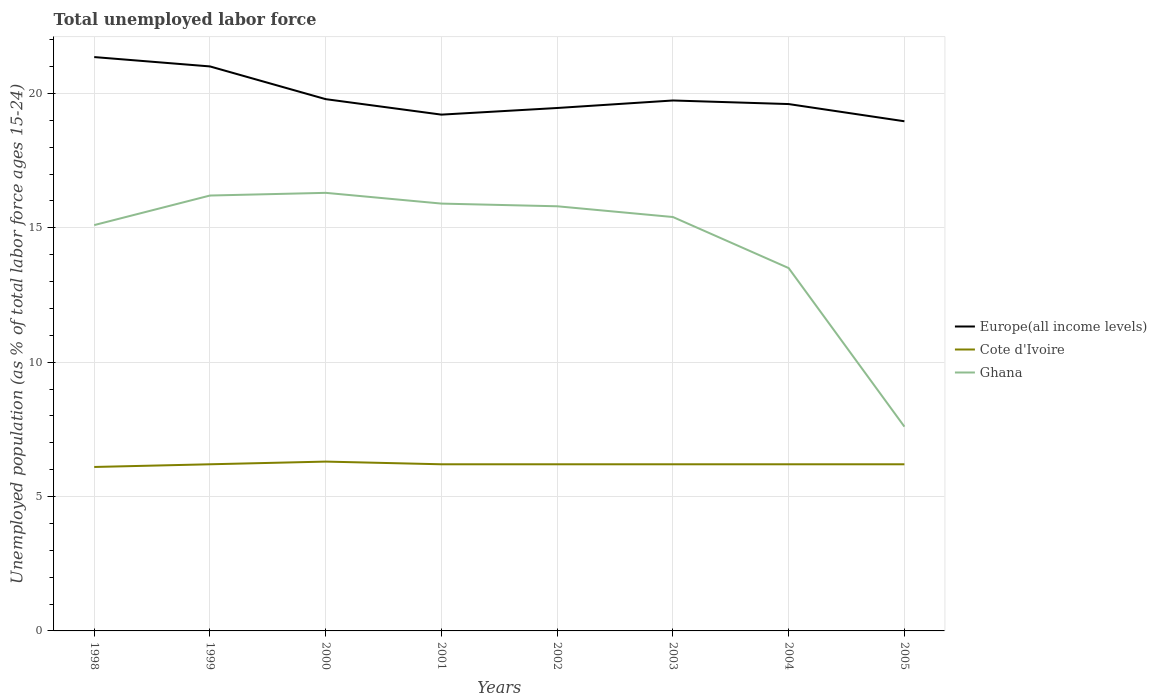Is the number of lines equal to the number of legend labels?
Ensure brevity in your answer.  Yes. Across all years, what is the maximum percentage of unemployed population in in Cote d'Ivoire?
Provide a short and direct response. 6.1. What is the total percentage of unemployed population in in Europe(all income levels) in the graph?
Make the answer very short. -0.39. What is the difference between the highest and the second highest percentage of unemployed population in in Ghana?
Keep it short and to the point. 8.7. How many lines are there?
Provide a succinct answer. 3. How many years are there in the graph?
Give a very brief answer. 8. What is the difference between two consecutive major ticks on the Y-axis?
Keep it short and to the point. 5. Are the values on the major ticks of Y-axis written in scientific E-notation?
Ensure brevity in your answer.  No. Does the graph contain any zero values?
Provide a short and direct response. No. Does the graph contain grids?
Offer a terse response. Yes. How are the legend labels stacked?
Offer a terse response. Vertical. What is the title of the graph?
Offer a very short reply. Total unemployed labor force. What is the label or title of the X-axis?
Offer a very short reply. Years. What is the label or title of the Y-axis?
Offer a terse response. Unemployed population (as % of total labor force ages 15-24). What is the Unemployed population (as % of total labor force ages 15-24) of Europe(all income levels) in 1998?
Provide a succinct answer. 21.35. What is the Unemployed population (as % of total labor force ages 15-24) in Cote d'Ivoire in 1998?
Provide a succinct answer. 6.1. What is the Unemployed population (as % of total labor force ages 15-24) in Ghana in 1998?
Make the answer very short. 15.1. What is the Unemployed population (as % of total labor force ages 15-24) of Europe(all income levels) in 1999?
Provide a succinct answer. 21. What is the Unemployed population (as % of total labor force ages 15-24) in Cote d'Ivoire in 1999?
Make the answer very short. 6.2. What is the Unemployed population (as % of total labor force ages 15-24) in Ghana in 1999?
Your response must be concise. 16.2. What is the Unemployed population (as % of total labor force ages 15-24) of Europe(all income levels) in 2000?
Offer a terse response. 19.79. What is the Unemployed population (as % of total labor force ages 15-24) in Cote d'Ivoire in 2000?
Offer a very short reply. 6.3. What is the Unemployed population (as % of total labor force ages 15-24) in Ghana in 2000?
Offer a terse response. 16.3. What is the Unemployed population (as % of total labor force ages 15-24) of Europe(all income levels) in 2001?
Your answer should be compact. 19.21. What is the Unemployed population (as % of total labor force ages 15-24) of Cote d'Ivoire in 2001?
Your answer should be compact. 6.2. What is the Unemployed population (as % of total labor force ages 15-24) of Ghana in 2001?
Your response must be concise. 15.9. What is the Unemployed population (as % of total labor force ages 15-24) of Europe(all income levels) in 2002?
Your response must be concise. 19.46. What is the Unemployed population (as % of total labor force ages 15-24) of Cote d'Ivoire in 2002?
Your response must be concise. 6.2. What is the Unemployed population (as % of total labor force ages 15-24) in Ghana in 2002?
Your response must be concise. 15.8. What is the Unemployed population (as % of total labor force ages 15-24) of Europe(all income levels) in 2003?
Keep it short and to the point. 19.74. What is the Unemployed population (as % of total labor force ages 15-24) of Cote d'Ivoire in 2003?
Offer a terse response. 6.2. What is the Unemployed population (as % of total labor force ages 15-24) of Ghana in 2003?
Offer a very short reply. 15.4. What is the Unemployed population (as % of total labor force ages 15-24) of Europe(all income levels) in 2004?
Your answer should be compact. 19.6. What is the Unemployed population (as % of total labor force ages 15-24) of Cote d'Ivoire in 2004?
Give a very brief answer. 6.2. What is the Unemployed population (as % of total labor force ages 15-24) of Europe(all income levels) in 2005?
Your answer should be very brief. 18.96. What is the Unemployed population (as % of total labor force ages 15-24) of Cote d'Ivoire in 2005?
Your answer should be very brief. 6.2. What is the Unemployed population (as % of total labor force ages 15-24) in Ghana in 2005?
Keep it short and to the point. 7.6. Across all years, what is the maximum Unemployed population (as % of total labor force ages 15-24) in Europe(all income levels)?
Your response must be concise. 21.35. Across all years, what is the maximum Unemployed population (as % of total labor force ages 15-24) in Cote d'Ivoire?
Offer a very short reply. 6.3. Across all years, what is the maximum Unemployed population (as % of total labor force ages 15-24) in Ghana?
Make the answer very short. 16.3. Across all years, what is the minimum Unemployed population (as % of total labor force ages 15-24) in Europe(all income levels)?
Ensure brevity in your answer.  18.96. Across all years, what is the minimum Unemployed population (as % of total labor force ages 15-24) in Cote d'Ivoire?
Make the answer very short. 6.1. Across all years, what is the minimum Unemployed population (as % of total labor force ages 15-24) of Ghana?
Keep it short and to the point. 7.6. What is the total Unemployed population (as % of total labor force ages 15-24) in Europe(all income levels) in the graph?
Offer a terse response. 159.11. What is the total Unemployed population (as % of total labor force ages 15-24) of Cote d'Ivoire in the graph?
Provide a succinct answer. 49.6. What is the total Unemployed population (as % of total labor force ages 15-24) of Ghana in the graph?
Offer a very short reply. 115.8. What is the difference between the Unemployed population (as % of total labor force ages 15-24) in Europe(all income levels) in 1998 and that in 1999?
Provide a succinct answer. 0.35. What is the difference between the Unemployed population (as % of total labor force ages 15-24) of Cote d'Ivoire in 1998 and that in 1999?
Your answer should be compact. -0.1. What is the difference between the Unemployed population (as % of total labor force ages 15-24) in Ghana in 1998 and that in 1999?
Provide a succinct answer. -1.1. What is the difference between the Unemployed population (as % of total labor force ages 15-24) of Europe(all income levels) in 1998 and that in 2000?
Your answer should be very brief. 1.57. What is the difference between the Unemployed population (as % of total labor force ages 15-24) in Europe(all income levels) in 1998 and that in 2001?
Offer a terse response. 2.14. What is the difference between the Unemployed population (as % of total labor force ages 15-24) of Ghana in 1998 and that in 2001?
Offer a very short reply. -0.8. What is the difference between the Unemployed population (as % of total labor force ages 15-24) of Europe(all income levels) in 1998 and that in 2002?
Provide a succinct answer. 1.89. What is the difference between the Unemployed population (as % of total labor force ages 15-24) in Cote d'Ivoire in 1998 and that in 2002?
Your response must be concise. -0.1. What is the difference between the Unemployed population (as % of total labor force ages 15-24) of Ghana in 1998 and that in 2002?
Ensure brevity in your answer.  -0.7. What is the difference between the Unemployed population (as % of total labor force ages 15-24) in Europe(all income levels) in 1998 and that in 2003?
Give a very brief answer. 1.62. What is the difference between the Unemployed population (as % of total labor force ages 15-24) in Ghana in 1998 and that in 2003?
Offer a very short reply. -0.3. What is the difference between the Unemployed population (as % of total labor force ages 15-24) in Europe(all income levels) in 1998 and that in 2004?
Your answer should be very brief. 1.75. What is the difference between the Unemployed population (as % of total labor force ages 15-24) of Cote d'Ivoire in 1998 and that in 2004?
Ensure brevity in your answer.  -0.1. What is the difference between the Unemployed population (as % of total labor force ages 15-24) in Europe(all income levels) in 1998 and that in 2005?
Give a very brief answer. 2.39. What is the difference between the Unemployed population (as % of total labor force ages 15-24) of Ghana in 1998 and that in 2005?
Offer a very short reply. 7.5. What is the difference between the Unemployed population (as % of total labor force ages 15-24) in Europe(all income levels) in 1999 and that in 2000?
Keep it short and to the point. 1.22. What is the difference between the Unemployed population (as % of total labor force ages 15-24) in Ghana in 1999 and that in 2000?
Make the answer very short. -0.1. What is the difference between the Unemployed population (as % of total labor force ages 15-24) in Europe(all income levels) in 1999 and that in 2001?
Provide a short and direct response. 1.79. What is the difference between the Unemployed population (as % of total labor force ages 15-24) in Cote d'Ivoire in 1999 and that in 2001?
Provide a succinct answer. 0. What is the difference between the Unemployed population (as % of total labor force ages 15-24) of Europe(all income levels) in 1999 and that in 2002?
Provide a succinct answer. 1.55. What is the difference between the Unemployed population (as % of total labor force ages 15-24) of Ghana in 1999 and that in 2002?
Your answer should be compact. 0.4. What is the difference between the Unemployed population (as % of total labor force ages 15-24) in Europe(all income levels) in 1999 and that in 2003?
Offer a very short reply. 1.27. What is the difference between the Unemployed population (as % of total labor force ages 15-24) of Cote d'Ivoire in 1999 and that in 2003?
Ensure brevity in your answer.  0. What is the difference between the Unemployed population (as % of total labor force ages 15-24) of Ghana in 1999 and that in 2003?
Provide a short and direct response. 0.8. What is the difference between the Unemployed population (as % of total labor force ages 15-24) in Europe(all income levels) in 1999 and that in 2004?
Your answer should be very brief. 1.4. What is the difference between the Unemployed population (as % of total labor force ages 15-24) in Ghana in 1999 and that in 2004?
Your answer should be compact. 2.7. What is the difference between the Unemployed population (as % of total labor force ages 15-24) in Europe(all income levels) in 1999 and that in 2005?
Your answer should be compact. 2.04. What is the difference between the Unemployed population (as % of total labor force ages 15-24) in Europe(all income levels) in 2000 and that in 2001?
Provide a short and direct response. 0.58. What is the difference between the Unemployed population (as % of total labor force ages 15-24) of Cote d'Ivoire in 2000 and that in 2001?
Offer a very short reply. 0.1. What is the difference between the Unemployed population (as % of total labor force ages 15-24) in Ghana in 2000 and that in 2001?
Give a very brief answer. 0.4. What is the difference between the Unemployed population (as % of total labor force ages 15-24) of Europe(all income levels) in 2000 and that in 2002?
Ensure brevity in your answer.  0.33. What is the difference between the Unemployed population (as % of total labor force ages 15-24) of Cote d'Ivoire in 2000 and that in 2002?
Offer a terse response. 0.1. What is the difference between the Unemployed population (as % of total labor force ages 15-24) in Europe(all income levels) in 2000 and that in 2003?
Your response must be concise. 0.05. What is the difference between the Unemployed population (as % of total labor force ages 15-24) in Cote d'Ivoire in 2000 and that in 2003?
Offer a very short reply. 0.1. What is the difference between the Unemployed population (as % of total labor force ages 15-24) of Europe(all income levels) in 2000 and that in 2004?
Ensure brevity in your answer.  0.18. What is the difference between the Unemployed population (as % of total labor force ages 15-24) in Ghana in 2000 and that in 2004?
Give a very brief answer. 2.8. What is the difference between the Unemployed population (as % of total labor force ages 15-24) in Europe(all income levels) in 2000 and that in 2005?
Offer a very short reply. 0.82. What is the difference between the Unemployed population (as % of total labor force ages 15-24) of Ghana in 2000 and that in 2005?
Your answer should be compact. 8.7. What is the difference between the Unemployed population (as % of total labor force ages 15-24) in Europe(all income levels) in 2001 and that in 2002?
Offer a very short reply. -0.25. What is the difference between the Unemployed population (as % of total labor force ages 15-24) in Cote d'Ivoire in 2001 and that in 2002?
Provide a short and direct response. 0. What is the difference between the Unemployed population (as % of total labor force ages 15-24) of Ghana in 2001 and that in 2002?
Ensure brevity in your answer.  0.1. What is the difference between the Unemployed population (as % of total labor force ages 15-24) in Europe(all income levels) in 2001 and that in 2003?
Your answer should be very brief. -0.53. What is the difference between the Unemployed population (as % of total labor force ages 15-24) of Europe(all income levels) in 2001 and that in 2004?
Provide a short and direct response. -0.39. What is the difference between the Unemployed population (as % of total labor force ages 15-24) in Cote d'Ivoire in 2001 and that in 2004?
Provide a short and direct response. 0. What is the difference between the Unemployed population (as % of total labor force ages 15-24) in Europe(all income levels) in 2001 and that in 2005?
Your answer should be very brief. 0.25. What is the difference between the Unemployed population (as % of total labor force ages 15-24) of Europe(all income levels) in 2002 and that in 2003?
Provide a short and direct response. -0.28. What is the difference between the Unemployed population (as % of total labor force ages 15-24) of Cote d'Ivoire in 2002 and that in 2003?
Ensure brevity in your answer.  0. What is the difference between the Unemployed population (as % of total labor force ages 15-24) of Europe(all income levels) in 2002 and that in 2004?
Your answer should be very brief. -0.15. What is the difference between the Unemployed population (as % of total labor force ages 15-24) of Ghana in 2002 and that in 2004?
Your answer should be compact. 2.3. What is the difference between the Unemployed population (as % of total labor force ages 15-24) of Europe(all income levels) in 2002 and that in 2005?
Your answer should be very brief. 0.49. What is the difference between the Unemployed population (as % of total labor force ages 15-24) in Cote d'Ivoire in 2002 and that in 2005?
Give a very brief answer. 0. What is the difference between the Unemployed population (as % of total labor force ages 15-24) in Ghana in 2002 and that in 2005?
Keep it short and to the point. 8.2. What is the difference between the Unemployed population (as % of total labor force ages 15-24) in Europe(all income levels) in 2003 and that in 2004?
Make the answer very short. 0.13. What is the difference between the Unemployed population (as % of total labor force ages 15-24) of Cote d'Ivoire in 2003 and that in 2004?
Give a very brief answer. 0. What is the difference between the Unemployed population (as % of total labor force ages 15-24) of Europe(all income levels) in 2003 and that in 2005?
Keep it short and to the point. 0.77. What is the difference between the Unemployed population (as % of total labor force ages 15-24) in Cote d'Ivoire in 2003 and that in 2005?
Provide a succinct answer. 0. What is the difference between the Unemployed population (as % of total labor force ages 15-24) in Ghana in 2003 and that in 2005?
Make the answer very short. 7.8. What is the difference between the Unemployed population (as % of total labor force ages 15-24) in Europe(all income levels) in 2004 and that in 2005?
Offer a very short reply. 0.64. What is the difference between the Unemployed population (as % of total labor force ages 15-24) of Ghana in 2004 and that in 2005?
Offer a terse response. 5.9. What is the difference between the Unemployed population (as % of total labor force ages 15-24) in Europe(all income levels) in 1998 and the Unemployed population (as % of total labor force ages 15-24) in Cote d'Ivoire in 1999?
Your response must be concise. 15.15. What is the difference between the Unemployed population (as % of total labor force ages 15-24) in Europe(all income levels) in 1998 and the Unemployed population (as % of total labor force ages 15-24) in Ghana in 1999?
Offer a very short reply. 5.15. What is the difference between the Unemployed population (as % of total labor force ages 15-24) of Europe(all income levels) in 1998 and the Unemployed population (as % of total labor force ages 15-24) of Cote d'Ivoire in 2000?
Provide a succinct answer. 15.05. What is the difference between the Unemployed population (as % of total labor force ages 15-24) in Europe(all income levels) in 1998 and the Unemployed population (as % of total labor force ages 15-24) in Ghana in 2000?
Offer a terse response. 5.05. What is the difference between the Unemployed population (as % of total labor force ages 15-24) of Europe(all income levels) in 1998 and the Unemployed population (as % of total labor force ages 15-24) of Cote d'Ivoire in 2001?
Provide a short and direct response. 15.15. What is the difference between the Unemployed population (as % of total labor force ages 15-24) of Europe(all income levels) in 1998 and the Unemployed population (as % of total labor force ages 15-24) of Ghana in 2001?
Provide a succinct answer. 5.45. What is the difference between the Unemployed population (as % of total labor force ages 15-24) of Europe(all income levels) in 1998 and the Unemployed population (as % of total labor force ages 15-24) of Cote d'Ivoire in 2002?
Ensure brevity in your answer.  15.15. What is the difference between the Unemployed population (as % of total labor force ages 15-24) of Europe(all income levels) in 1998 and the Unemployed population (as % of total labor force ages 15-24) of Ghana in 2002?
Offer a terse response. 5.55. What is the difference between the Unemployed population (as % of total labor force ages 15-24) in Cote d'Ivoire in 1998 and the Unemployed population (as % of total labor force ages 15-24) in Ghana in 2002?
Your answer should be very brief. -9.7. What is the difference between the Unemployed population (as % of total labor force ages 15-24) in Europe(all income levels) in 1998 and the Unemployed population (as % of total labor force ages 15-24) in Cote d'Ivoire in 2003?
Give a very brief answer. 15.15. What is the difference between the Unemployed population (as % of total labor force ages 15-24) of Europe(all income levels) in 1998 and the Unemployed population (as % of total labor force ages 15-24) of Ghana in 2003?
Provide a succinct answer. 5.95. What is the difference between the Unemployed population (as % of total labor force ages 15-24) of Europe(all income levels) in 1998 and the Unemployed population (as % of total labor force ages 15-24) of Cote d'Ivoire in 2004?
Offer a terse response. 15.15. What is the difference between the Unemployed population (as % of total labor force ages 15-24) in Europe(all income levels) in 1998 and the Unemployed population (as % of total labor force ages 15-24) in Ghana in 2004?
Your response must be concise. 7.85. What is the difference between the Unemployed population (as % of total labor force ages 15-24) in Cote d'Ivoire in 1998 and the Unemployed population (as % of total labor force ages 15-24) in Ghana in 2004?
Ensure brevity in your answer.  -7.4. What is the difference between the Unemployed population (as % of total labor force ages 15-24) of Europe(all income levels) in 1998 and the Unemployed population (as % of total labor force ages 15-24) of Cote d'Ivoire in 2005?
Offer a very short reply. 15.15. What is the difference between the Unemployed population (as % of total labor force ages 15-24) of Europe(all income levels) in 1998 and the Unemployed population (as % of total labor force ages 15-24) of Ghana in 2005?
Your answer should be very brief. 13.75. What is the difference between the Unemployed population (as % of total labor force ages 15-24) of Europe(all income levels) in 1999 and the Unemployed population (as % of total labor force ages 15-24) of Cote d'Ivoire in 2000?
Offer a terse response. 14.7. What is the difference between the Unemployed population (as % of total labor force ages 15-24) in Europe(all income levels) in 1999 and the Unemployed population (as % of total labor force ages 15-24) in Ghana in 2000?
Make the answer very short. 4.7. What is the difference between the Unemployed population (as % of total labor force ages 15-24) in Cote d'Ivoire in 1999 and the Unemployed population (as % of total labor force ages 15-24) in Ghana in 2000?
Provide a succinct answer. -10.1. What is the difference between the Unemployed population (as % of total labor force ages 15-24) of Europe(all income levels) in 1999 and the Unemployed population (as % of total labor force ages 15-24) of Cote d'Ivoire in 2001?
Make the answer very short. 14.8. What is the difference between the Unemployed population (as % of total labor force ages 15-24) in Europe(all income levels) in 1999 and the Unemployed population (as % of total labor force ages 15-24) in Ghana in 2001?
Your answer should be compact. 5.1. What is the difference between the Unemployed population (as % of total labor force ages 15-24) in Europe(all income levels) in 1999 and the Unemployed population (as % of total labor force ages 15-24) in Cote d'Ivoire in 2002?
Provide a succinct answer. 14.8. What is the difference between the Unemployed population (as % of total labor force ages 15-24) in Europe(all income levels) in 1999 and the Unemployed population (as % of total labor force ages 15-24) in Ghana in 2002?
Your response must be concise. 5.2. What is the difference between the Unemployed population (as % of total labor force ages 15-24) of Cote d'Ivoire in 1999 and the Unemployed population (as % of total labor force ages 15-24) of Ghana in 2002?
Provide a succinct answer. -9.6. What is the difference between the Unemployed population (as % of total labor force ages 15-24) in Europe(all income levels) in 1999 and the Unemployed population (as % of total labor force ages 15-24) in Cote d'Ivoire in 2003?
Offer a very short reply. 14.8. What is the difference between the Unemployed population (as % of total labor force ages 15-24) of Europe(all income levels) in 1999 and the Unemployed population (as % of total labor force ages 15-24) of Ghana in 2003?
Keep it short and to the point. 5.6. What is the difference between the Unemployed population (as % of total labor force ages 15-24) in Cote d'Ivoire in 1999 and the Unemployed population (as % of total labor force ages 15-24) in Ghana in 2003?
Your answer should be very brief. -9.2. What is the difference between the Unemployed population (as % of total labor force ages 15-24) in Europe(all income levels) in 1999 and the Unemployed population (as % of total labor force ages 15-24) in Cote d'Ivoire in 2004?
Offer a terse response. 14.8. What is the difference between the Unemployed population (as % of total labor force ages 15-24) in Europe(all income levels) in 1999 and the Unemployed population (as % of total labor force ages 15-24) in Ghana in 2004?
Your answer should be compact. 7.5. What is the difference between the Unemployed population (as % of total labor force ages 15-24) of Europe(all income levels) in 1999 and the Unemployed population (as % of total labor force ages 15-24) of Cote d'Ivoire in 2005?
Your answer should be compact. 14.8. What is the difference between the Unemployed population (as % of total labor force ages 15-24) of Europe(all income levels) in 1999 and the Unemployed population (as % of total labor force ages 15-24) of Ghana in 2005?
Make the answer very short. 13.4. What is the difference between the Unemployed population (as % of total labor force ages 15-24) in Europe(all income levels) in 2000 and the Unemployed population (as % of total labor force ages 15-24) in Cote d'Ivoire in 2001?
Ensure brevity in your answer.  13.59. What is the difference between the Unemployed population (as % of total labor force ages 15-24) of Europe(all income levels) in 2000 and the Unemployed population (as % of total labor force ages 15-24) of Ghana in 2001?
Keep it short and to the point. 3.89. What is the difference between the Unemployed population (as % of total labor force ages 15-24) of Cote d'Ivoire in 2000 and the Unemployed population (as % of total labor force ages 15-24) of Ghana in 2001?
Keep it short and to the point. -9.6. What is the difference between the Unemployed population (as % of total labor force ages 15-24) in Europe(all income levels) in 2000 and the Unemployed population (as % of total labor force ages 15-24) in Cote d'Ivoire in 2002?
Provide a succinct answer. 13.59. What is the difference between the Unemployed population (as % of total labor force ages 15-24) in Europe(all income levels) in 2000 and the Unemployed population (as % of total labor force ages 15-24) in Ghana in 2002?
Provide a short and direct response. 3.99. What is the difference between the Unemployed population (as % of total labor force ages 15-24) in Europe(all income levels) in 2000 and the Unemployed population (as % of total labor force ages 15-24) in Cote d'Ivoire in 2003?
Offer a very short reply. 13.59. What is the difference between the Unemployed population (as % of total labor force ages 15-24) in Europe(all income levels) in 2000 and the Unemployed population (as % of total labor force ages 15-24) in Ghana in 2003?
Your answer should be very brief. 4.39. What is the difference between the Unemployed population (as % of total labor force ages 15-24) of Europe(all income levels) in 2000 and the Unemployed population (as % of total labor force ages 15-24) of Cote d'Ivoire in 2004?
Keep it short and to the point. 13.59. What is the difference between the Unemployed population (as % of total labor force ages 15-24) in Europe(all income levels) in 2000 and the Unemployed population (as % of total labor force ages 15-24) in Ghana in 2004?
Keep it short and to the point. 6.29. What is the difference between the Unemployed population (as % of total labor force ages 15-24) in Cote d'Ivoire in 2000 and the Unemployed population (as % of total labor force ages 15-24) in Ghana in 2004?
Provide a short and direct response. -7.2. What is the difference between the Unemployed population (as % of total labor force ages 15-24) of Europe(all income levels) in 2000 and the Unemployed population (as % of total labor force ages 15-24) of Cote d'Ivoire in 2005?
Provide a succinct answer. 13.59. What is the difference between the Unemployed population (as % of total labor force ages 15-24) of Europe(all income levels) in 2000 and the Unemployed population (as % of total labor force ages 15-24) of Ghana in 2005?
Give a very brief answer. 12.19. What is the difference between the Unemployed population (as % of total labor force ages 15-24) of Europe(all income levels) in 2001 and the Unemployed population (as % of total labor force ages 15-24) of Cote d'Ivoire in 2002?
Provide a short and direct response. 13.01. What is the difference between the Unemployed population (as % of total labor force ages 15-24) in Europe(all income levels) in 2001 and the Unemployed population (as % of total labor force ages 15-24) in Ghana in 2002?
Provide a short and direct response. 3.41. What is the difference between the Unemployed population (as % of total labor force ages 15-24) of Europe(all income levels) in 2001 and the Unemployed population (as % of total labor force ages 15-24) of Cote d'Ivoire in 2003?
Ensure brevity in your answer.  13.01. What is the difference between the Unemployed population (as % of total labor force ages 15-24) in Europe(all income levels) in 2001 and the Unemployed population (as % of total labor force ages 15-24) in Ghana in 2003?
Keep it short and to the point. 3.81. What is the difference between the Unemployed population (as % of total labor force ages 15-24) in Cote d'Ivoire in 2001 and the Unemployed population (as % of total labor force ages 15-24) in Ghana in 2003?
Offer a very short reply. -9.2. What is the difference between the Unemployed population (as % of total labor force ages 15-24) in Europe(all income levels) in 2001 and the Unemployed population (as % of total labor force ages 15-24) in Cote d'Ivoire in 2004?
Offer a terse response. 13.01. What is the difference between the Unemployed population (as % of total labor force ages 15-24) of Europe(all income levels) in 2001 and the Unemployed population (as % of total labor force ages 15-24) of Ghana in 2004?
Keep it short and to the point. 5.71. What is the difference between the Unemployed population (as % of total labor force ages 15-24) in Europe(all income levels) in 2001 and the Unemployed population (as % of total labor force ages 15-24) in Cote d'Ivoire in 2005?
Your answer should be compact. 13.01. What is the difference between the Unemployed population (as % of total labor force ages 15-24) of Europe(all income levels) in 2001 and the Unemployed population (as % of total labor force ages 15-24) of Ghana in 2005?
Provide a succinct answer. 11.61. What is the difference between the Unemployed population (as % of total labor force ages 15-24) in Cote d'Ivoire in 2001 and the Unemployed population (as % of total labor force ages 15-24) in Ghana in 2005?
Your answer should be very brief. -1.4. What is the difference between the Unemployed population (as % of total labor force ages 15-24) of Europe(all income levels) in 2002 and the Unemployed population (as % of total labor force ages 15-24) of Cote d'Ivoire in 2003?
Provide a short and direct response. 13.26. What is the difference between the Unemployed population (as % of total labor force ages 15-24) in Europe(all income levels) in 2002 and the Unemployed population (as % of total labor force ages 15-24) in Ghana in 2003?
Offer a terse response. 4.06. What is the difference between the Unemployed population (as % of total labor force ages 15-24) of Cote d'Ivoire in 2002 and the Unemployed population (as % of total labor force ages 15-24) of Ghana in 2003?
Offer a very short reply. -9.2. What is the difference between the Unemployed population (as % of total labor force ages 15-24) in Europe(all income levels) in 2002 and the Unemployed population (as % of total labor force ages 15-24) in Cote d'Ivoire in 2004?
Your answer should be compact. 13.26. What is the difference between the Unemployed population (as % of total labor force ages 15-24) of Europe(all income levels) in 2002 and the Unemployed population (as % of total labor force ages 15-24) of Ghana in 2004?
Ensure brevity in your answer.  5.96. What is the difference between the Unemployed population (as % of total labor force ages 15-24) of Europe(all income levels) in 2002 and the Unemployed population (as % of total labor force ages 15-24) of Cote d'Ivoire in 2005?
Offer a terse response. 13.26. What is the difference between the Unemployed population (as % of total labor force ages 15-24) of Europe(all income levels) in 2002 and the Unemployed population (as % of total labor force ages 15-24) of Ghana in 2005?
Offer a very short reply. 11.86. What is the difference between the Unemployed population (as % of total labor force ages 15-24) in Cote d'Ivoire in 2002 and the Unemployed population (as % of total labor force ages 15-24) in Ghana in 2005?
Offer a very short reply. -1.4. What is the difference between the Unemployed population (as % of total labor force ages 15-24) of Europe(all income levels) in 2003 and the Unemployed population (as % of total labor force ages 15-24) of Cote d'Ivoire in 2004?
Offer a terse response. 13.54. What is the difference between the Unemployed population (as % of total labor force ages 15-24) in Europe(all income levels) in 2003 and the Unemployed population (as % of total labor force ages 15-24) in Ghana in 2004?
Make the answer very short. 6.24. What is the difference between the Unemployed population (as % of total labor force ages 15-24) in Cote d'Ivoire in 2003 and the Unemployed population (as % of total labor force ages 15-24) in Ghana in 2004?
Offer a very short reply. -7.3. What is the difference between the Unemployed population (as % of total labor force ages 15-24) in Europe(all income levels) in 2003 and the Unemployed population (as % of total labor force ages 15-24) in Cote d'Ivoire in 2005?
Provide a succinct answer. 13.54. What is the difference between the Unemployed population (as % of total labor force ages 15-24) of Europe(all income levels) in 2003 and the Unemployed population (as % of total labor force ages 15-24) of Ghana in 2005?
Ensure brevity in your answer.  12.14. What is the difference between the Unemployed population (as % of total labor force ages 15-24) of Europe(all income levels) in 2004 and the Unemployed population (as % of total labor force ages 15-24) of Cote d'Ivoire in 2005?
Provide a succinct answer. 13.4. What is the difference between the Unemployed population (as % of total labor force ages 15-24) of Europe(all income levels) in 2004 and the Unemployed population (as % of total labor force ages 15-24) of Ghana in 2005?
Provide a short and direct response. 12. What is the difference between the Unemployed population (as % of total labor force ages 15-24) of Cote d'Ivoire in 2004 and the Unemployed population (as % of total labor force ages 15-24) of Ghana in 2005?
Your answer should be compact. -1.4. What is the average Unemployed population (as % of total labor force ages 15-24) of Europe(all income levels) per year?
Ensure brevity in your answer.  19.89. What is the average Unemployed population (as % of total labor force ages 15-24) of Cote d'Ivoire per year?
Your answer should be compact. 6.2. What is the average Unemployed population (as % of total labor force ages 15-24) of Ghana per year?
Provide a short and direct response. 14.47. In the year 1998, what is the difference between the Unemployed population (as % of total labor force ages 15-24) of Europe(all income levels) and Unemployed population (as % of total labor force ages 15-24) of Cote d'Ivoire?
Ensure brevity in your answer.  15.25. In the year 1998, what is the difference between the Unemployed population (as % of total labor force ages 15-24) in Europe(all income levels) and Unemployed population (as % of total labor force ages 15-24) in Ghana?
Provide a succinct answer. 6.25. In the year 1999, what is the difference between the Unemployed population (as % of total labor force ages 15-24) of Europe(all income levels) and Unemployed population (as % of total labor force ages 15-24) of Cote d'Ivoire?
Keep it short and to the point. 14.8. In the year 1999, what is the difference between the Unemployed population (as % of total labor force ages 15-24) in Europe(all income levels) and Unemployed population (as % of total labor force ages 15-24) in Ghana?
Your answer should be compact. 4.8. In the year 1999, what is the difference between the Unemployed population (as % of total labor force ages 15-24) of Cote d'Ivoire and Unemployed population (as % of total labor force ages 15-24) of Ghana?
Provide a succinct answer. -10. In the year 2000, what is the difference between the Unemployed population (as % of total labor force ages 15-24) of Europe(all income levels) and Unemployed population (as % of total labor force ages 15-24) of Cote d'Ivoire?
Keep it short and to the point. 13.49. In the year 2000, what is the difference between the Unemployed population (as % of total labor force ages 15-24) in Europe(all income levels) and Unemployed population (as % of total labor force ages 15-24) in Ghana?
Your answer should be compact. 3.49. In the year 2000, what is the difference between the Unemployed population (as % of total labor force ages 15-24) of Cote d'Ivoire and Unemployed population (as % of total labor force ages 15-24) of Ghana?
Give a very brief answer. -10. In the year 2001, what is the difference between the Unemployed population (as % of total labor force ages 15-24) in Europe(all income levels) and Unemployed population (as % of total labor force ages 15-24) in Cote d'Ivoire?
Provide a succinct answer. 13.01. In the year 2001, what is the difference between the Unemployed population (as % of total labor force ages 15-24) of Europe(all income levels) and Unemployed population (as % of total labor force ages 15-24) of Ghana?
Your answer should be very brief. 3.31. In the year 2001, what is the difference between the Unemployed population (as % of total labor force ages 15-24) in Cote d'Ivoire and Unemployed population (as % of total labor force ages 15-24) in Ghana?
Your answer should be very brief. -9.7. In the year 2002, what is the difference between the Unemployed population (as % of total labor force ages 15-24) in Europe(all income levels) and Unemployed population (as % of total labor force ages 15-24) in Cote d'Ivoire?
Ensure brevity in your answer.  13.26. In the year 2002, what is the difference between the Unemployed population (as % of total labor force ages 15-24) of Europe(all income levels) and Unemployed population (as % of total labor force ages 15-24) of Ghana?
Offer a terse response. 3.66. In the year 2003, what is the difference between the Unemployed population (as % of total labor force ages 15-24) in Europe(all income levels) and Unemployed population (as % of total labor force ages 15-24) in Cote d'Ivoire?
Your answer should be very brief. 13.54. In the year 2003, what is the difference between the Unemployed population (as % of total labor force ages 15-24) of Europe(all income levels) and Unemployed population (as % of total labor force ages 15-24) of Ghana?
Your answer should be very brief. 4.34. In the year 2003, what is the difference between the Unemployed population (as % of total labor force ages 15-24) of Cote d'Ivoire and Unemployed population (as % of total labor force ages 15-24) of Ghana?
Your answer should be compact. -9.2. In the year 2004, what is the difference between the Unemployed population (as % of total labor force ages 15-24) of Europe(all income levels) and Unemployed population (as % of total labor force ages 15-24) of Cote d'Ivoire?
Give a very brief answer. 13.4. In the year 2004, what is the difference between the Unemployed population (as % of total labor force ages 15-24) in Europe(all income levels) and Unemployed population (as % of total labor force ages 15-24) in Ghana?
Provide a succinct answer. 6.1. In the year 2004, what is the difference between the Unemployed population (as % of total labor force ages 15-24) of Cote d'Ivoire and Unemployed population (as % of total labor force ages 15-24) of Ghana?
Keep it short and to the point. -7.3. In the year 2005, what is the difference between the Unemployed population (as % of total labor force ages 15-24) of Europe(all income levels) and Unemployed population (as % of total labor force ages 15-24) of Cote d'Ivoire?
Your answer should be compact. 12.76. In the year 2005, what is the difference between the Unemployed population (as % of total labor force ages 15-24) of Europe(all income levels) and Unemployed population (as % of total labor force ages 15-24) of Ghana?
Make the answer very short. 11.36. In the year 2005, what is the difference between the Unemployed population (as % of total labor force ages 15-24) in Cote d'Ivoire and Unemployed population (as % of total labor force ages 15-24) in Ghana?
Your response must be concise. -1.4. What is the ratio of the Unemployed population (as % of total labor force ages 15-24) of Europe(all income levels) in 1998 to that in 1999?
Your response must be concise. 1.02. What is the ratio of the Unemployed population (as % of total labor force ages 15-24) in Cote d'Ivoire in 1998 to that in 1999?
Ensure brevity in your answer.  0.98. What is the ratio of the Unemployed population (as % of total labor force ages 15-24) of Ghana in 1998 to that in 1999?
Your answer should be very brief. 0.93. What is the ratio of the Unemployed population (as % of total labor force ages 15-24) in Europe(all income levels) in 1998 to that in 2000?
Your answer should be very brief. 1.08. What is the ratio of the Unemployed population (as % of total labor force ages 15-24) in Cote d'Ivoire in 1998 to that in 2000?
Make the answer very short. 0.97. What is the ratio of the Unemployed population (as % of total labor force ages 15-24) in Ghana in 1998 to that in 2000?
Your answer should be very brief. 0.93. What is the ratio of the Unemployed population (as % of total labor force ages 15-24) in Europe(all income levels) in 1998 to that in 2001?
Make the answer very short. 1.11. What is the ratio of the Unemployed population (as % of total labor force ages 15-24) of Cote d'Ivoire in 1998 to that in 2001?
Your answer should be compact. 0.98. What is the ratio of the Unemployed population (as % of total labor force ages 15-24) of Ghana in 1998 to that in 2001?
Offer a terse response. 0.95. What is the ratio of the Unemployed population (as % of total labor force ages 15-24) in Europe(all income levels) in 1998 to that in 2002?
Keep it short and to the point. 1.1. What is the ratio of the Unemployed population (as % of total labor force ages 15-24) in Cote d'Ivoire in 1998 to that in 2002?
Keep it short and to the point. 0.98. What is the ratio of the Unemployed population (as % of total labor force ages 15-24) in Ghana in 1998 to that in 2002?
Your answer should be very brief. 0.96. What is the ratio of the Unemployed population (as % of total labor force ages 15-24) in Europe(all income levels) in 1998 to that in 2003?
Your response must be concise. 1.08. What is the ratio of the Unemployed population (as % of total labor force ages 15-24) of Cote d'Ivoire in 1998 to that in 2003?
Offer a terse response. 0.98. What is the ratio of the Unemployed population (as % of total labor force ages 15-24) in Ghana in 1998 to that in 2003?
Your answer should be very brief. 0.98. What is the ratio of the Unemployed population (as % of total labor force ages 15-24) in Europe(all income levels) in 1998 to that in 2004?
Keep it short and to the point. 1.09. What is the ratio of the Unemployed population (as % of total labor force ages 15-24) in Cote d'Ivoire in 1998 to that in 2004?
Your answer should be compact. 0.98. What is the ratio of the Unemployed population (as % of total labor force ages 15-24) in Ghana in 1998 to that in 2004?
Offer a terse response. 1.12. What is the ratio of the Unemployed population (as % of total labor force ages 15-24) of Europe(all income levels) in 1998 to that in 2005?
Provide a succinct answer. 1.13. What is the ratio of the Unemployed population (as % of total labor force ages 15-24) of Cote d'Ivoire in 1998 to that in 2005?
Offer a terse response. 0.98. What is the ratio of the Unemployed population (as % of total labor force ages 15-24) of Ghana in 1998 to that in 2005?
Offer a very short reply. 1.99. What is the ratio of the Unemployed population (as % of total labor force ages 15-24) of Europe(all income levels) in 1999 to that in 2000?
Offer a very short reply. 1.06. What is the ratio of the Unemployed population (as % of total labor force ages 15-24) of Cote d'Ivoire in 1999 to that in 2000?
Give a very brief answer. 0.98. What is the ratio of the Unemployed population (as % of total labor force ages 15-24) of Europe(all income levels) in 1999 to that in 2001?
Your response must be concise. 1.09. What is the ratio of the Unemployed population (as % of total labor force ages 15-24) of Ghana in 1999 to that in 2001?
Your response must be concise. 1.02. What is the ratio of the Unemployed population (as % of total labor force ages 15-24) in Europe(all income levels) in 1999 to that in 2002?
Ensure brevity in your answer.  1.08. What is the ratio of the Unemployed population (as % of total labor force ages 15-24) in Ghana in 1999 to that in 2002?
Your answer should be very brief. 1.03. What is the ratio of the Unemployed population (as % of total labor force ages 15-24) in Europe(all income levels) in 1999 to that in 2003?
Your answer should be very brief. 1.06. What is the ratio of the Unemployed population (as % of total labor force ages 15-24) of Ghana in 1999 to that in 2003?
Offer a terse response. 1.05. What is the ratio of the Unemployed population (as % of total labor force ages 15-24) in Europe(all income levels) in 1999 to that in 2004?
Your answer should be compact. 1.07. What is the ratio of the Unemployed population (as % of total labor force ages 15-24) in Cote d'Ivoire in 1999 to that in 2004?
Ensure brevity in your answer.  1. What is the ratio of the Unemployed population (as % of total labor force ages 15-24) of Europe(all income levels) in 1999 to that in 2005?
Make the answer very short. 1.11. What is the ratio of the Unemployed population (as % of total labor force ages 15-24) of Cote d'Ivoire in 1999 to that in 2005?
Offer a very short reply. 1. What is the ratio of the Unemployed population (as % of total labor force ages 15-24) of Ghana in 1999 to that in 2005?
Offer a terse response. 2.13. What is the ratio of the Unemployed population (as % of total labor force ages 15-24) in Europe(all income levels) in 2000 to that in 2001?
Offer a terse response. 1.03. What is the ratio of the Unemployed population (as % of total labor force ages 15-24) in Cote d'Ivoire in 2000 to that in 2001?
Keep it short and to the point. 1.02. What is the ratio of the Unemployed population (as % of total labor force ages 15-24) in Ghana in 2000 to that in 2001?
Keep it short and to the point. 1.03. What is the ratio of the Unemployed population (as % of total labor force ages 15-24) of Europe(all income levels) in 2000 to that in 2002?
Offer a very short reply. 1.02. What is the ratio of the Unemployed population (as % of total labor force ages 15-24) in Cote d'Ivoire in 2000 to that in 2002?
Offer a terse response. 1.02. What is the ratio of the Unemployed population (as % of total labor force ages 15-24) of Ghana in 2000 to that in 2002?
Offer a terse response. 1.03. What is the ratio of the Unemployed population (as % of total labor force ages 15-24) in Europe(all income levels) in 2000 to that in 2003?
Make the answer very short. 1. What is the ratio of the Unemployed population (as % of total labor force ages 15-24) in Cote d'Ivoire in 2000 to that in 2003?
Your response must be concise. 1.02. What is the ratio of the Unemployed population (as % of total labor force ages 15-24) in Ghana in 2000 to that in 2003?
Give a very brief answer. 1.06. What is the ratio of the Unemployed population (as % of total labor force ages 15-24) in Europe(all income levels) in 2000 to that in 2004?
Your response must be concise. 1.01. What is the ratio of the Unemployed population (as % of total labor force ages 15-24) in Cote d'Ivoire in 2000 to that in 2004?
Offer a very short reply. 1.02. What is the ratio of the Unemployed population (as % of total labor force ages 15-24) of Ghana in 2000 to that in 2004?
Your answer should be compact. 1.21. What is the ratio of the Unemployed population (as % of total labor force ages 15-24) in Europe(all income levels) in 2000 to that in 2005?
Keep it short and to the point. 1.04. What is the ratio of the Unemployed population (as % of total labor force ages 15-24) of Cote d'Ivoire in 2000 to that in 2005?
Your answer should be compact. 1.02. What is the ratio of the Unemployed population (as % of total labor force ages 15-24) of Ghana in 2000 to that in 2005?
Keep it short and to the point. 2.14. What is the ratio of the Unemployed population (as % of total labor force ages 15-24) in Europe(all income levels) in 2001 to that in 2002?
Offer a very short reply. 0.99. What is the ratio of the Unemployed population (as % of total labor force ages 15-24) in Europe(all income levels) in 2001 to that in 2003?
Offer a very short reply. 0.97. What is the ratio of the Unemployed population (as % of total labor force ages 15-24) of Cote d'Ivoire in 2001 to that in 2003?
Give a very brief answer. 1. What is the ratio of the Unemployed population (as % of total labor force ages 15-24) in Ghana in 2001 to that in 2003?
Your answer should be compact. 1.03. What is the ratio of the Unemployed population (as % of total labor force ages 15-24) of Europe(all income levels) in 2001 to that in 2004?
Offer a terse response. 0.98. What is the ratio of the Unemployed population (as % of total labor force ages 15-24) of Cote d'Ivoire in 2001 to that in 2004?
Offer a terse response. 1. What is the ratio of the Unemployed population (as % of total labor force ages 15-24) of Ghana in 2001 to that in 2004?
Make the answer very short. 1.18. What is the ratio of the Unemployed population (as % of total labor force ages 15-24) in Europe(all income levels) in 2001 to that in 2005?
Make the answer very short. 1.01. What is the ratio of the Unemployed population (as % of total labor force ages 15-24) of Cote d'Ivoire in 2001 to that in 2005?
Offer a very short reply. 1. What is the ratio of the Unemployed population (as % of total labor force ages 15-24) of Ghana in 2001 to that in 2005?
Your answer should be compact. 2.09. What is the ratio of the Unemployed population (as % of total labor force ages 15-24) in Europe(all income levels) in 2002 to that in 2003?
Give a very brief answer. 0.99. What is the ratio of the Unemployed population (as % of total labor force ages 15-24) in Cote d'Ivoire in 2002 to that in 2003?
Your answer should be very brief. 1. What is the ratio of the Unemployed population (as % of total labor force ages 15-24) of Cote d'Ivoire in 2002 to that in 2004?
Make the answer very short. 1. What is the ratio of the Unemployed population (as % of total labor force ages 15-24) of Ghana in 2002 to that in 2004?
Make the answer very short. 1.17. What is the ratio of the Unemployed population (as % of total labor force ages 15-24) in Europe(all income levels) in 2002 to that in 2005?
Keep it short and to the point. 1.03. What is the ratio of the Unemployed population (as % of total labor force ages 15-24) of Cote d'Ivoire in 2002 to that in 2005?
Make the answer very short. 1. What is the ratio of the Unemployed population (as % of total labor force ages 15-24) of Ghana in 2002 to that in 2005?
Provide a short and direct response. 2.08. What is the ratio of the Unemployed population (as % of total labor force ages 15-24) in Europe(all income levels) in 2003 to that in 2004?
Your response must be concise. 1.01. What is the ratio of the Unemployed population (as % of total labor force ages 15-24) of Ghana in 2003 to that in 2004?
Your answer should be compact. 1.14. What is the ratio of the Unemployed population (as % of total labor force ages 15-24) in Europe(all income levels) in 2003 to that in 2005?
Your response must be concise. 1.04. What is the ratio of the Unemployed population (as % of total labor force ages 15-24) of Cote d'Ivoire in 2003 to that in 2005?
Your answer should be compact. 1. What is the ratio of the Unemployed population (as % of total labor force ages 15-24) of Ghana in 2003 to that in 2005?
Provide a short and direct response. 2.03. What is the ratio of the Unemployed population (as % of total labor force ages 15-24) in Europe(all income levels) in 2004 to that in 2005?
Your answer should be compact. 1.03. What is the ratio of the Unemployed population (as % of total labor force ages 15-24) of Ghana in 2004 to that in 2005?
Ensure brevity in your answer.  1.78. What is the difference between the highest and the second highest Unemployed population (as % of total labor force ages 15-24) of Europe(all income levels)?
Your response must be concise. 0.35. What is the difference between the highest and the second highest Unemployed population (as % of total labor force ages 15-24) in Cote d'Ivoire?
Your answer should be compact. 0.1. What is the difference between the highest and the lowest Unemployed population (as % of total labor force ages 15-24) of Europe(all income levels)?
Your response must be concise. 2.39. What is the difference between the highest and the lowest Unemployed population (as % of total labor force ages 15-24) in Cote d'Ivoire?
Offer a very short reply. 0.2. 